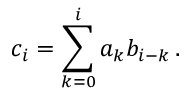Convert formula to latex. <formula><loc_0><loc_0><loc_500><loc_500>c _ { i } = \sum _ { k = 0 } ^ { i } a _ { k } b _ { i - k } \, .</formula> 